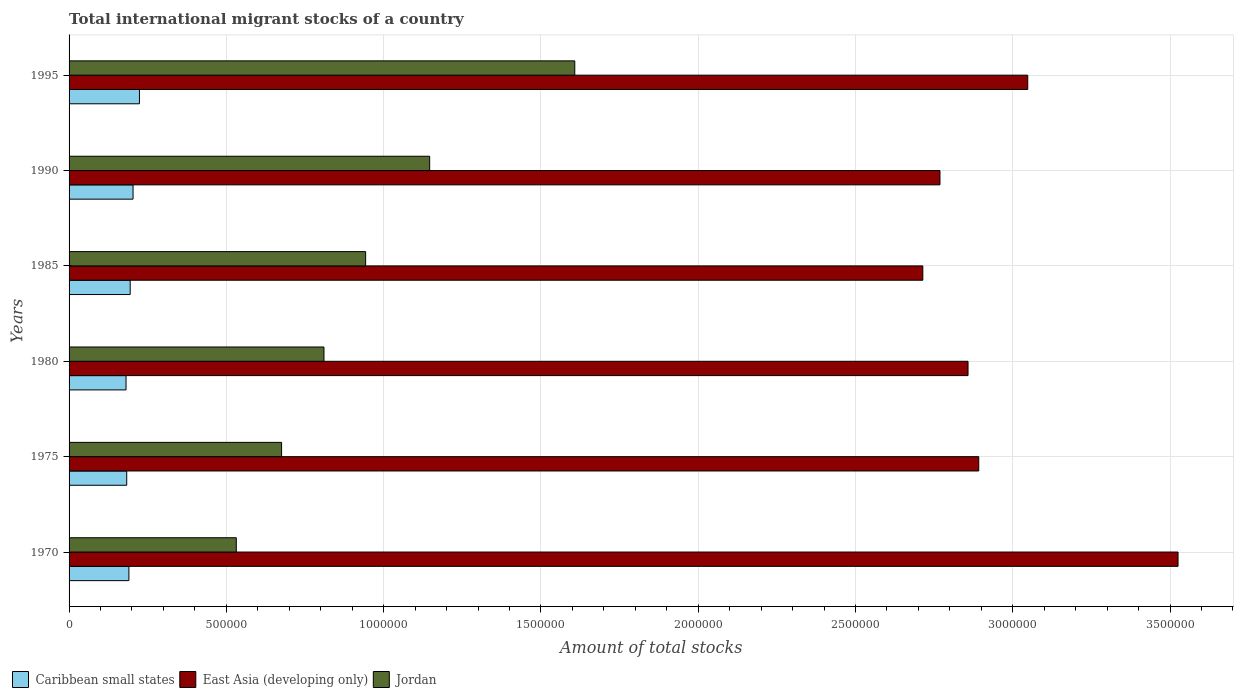How many bars are there on the 6th tick from the top?
Your answer should be compact. 3. How many bars are there on the 2nd tick from the bottom?
Make the answer very short. 3. In how many cases, is the number of bars for a given year not equal to the number of legend labels?
Your response must be concise. 0. What is the amount of total stocks in in Jordan in 1970?
Provide a short and direct response. 5.32e+05. Across all years, what is the maximum amount of total stocks in in Jordan?
Ensure brevity in your answer.  1.61e+06. Across all years, what is the minimum amount of total stocks in in Jordan?
Your answer should be very brief. 5.32e+05. What is the total amount of total stocks in in Caribbean small states in the graph?
Your answer should be very brief. 1.18e+06. What is the difference between the amount of total stocks in in Jordan in 1980 and that in 1985?
Offer a very short reply. -1.32e+05. What is the difference between the amount of total stocks in in Jordan in 1970 and the amount of total stocks in in East Asia (developing only) in 1995?
Make the answer very short. -2.52e+06. What is the average amount of total stocks in in Jordan per year?
Keep it short and to the point. 9.52e+05. In the year 1970, what is the difference between the amount of total stocks in in Caribbean small states and amount of total stocks in in East Asia (developing only)?
Offer a terse response. -3.34e+06. In how many years, is the amount of total stocks in in Caribbean small states greater than 300000 ?
Your answer should be compact. 0. What is the ratio of the amount of total stocks in in Jordan in 1970 to that in 1985?
Keep it short and to the point. 0.56. Is the difference between the amount of total stocks in in Caribbean small states in 1975 and 1990 greater than the difference between the amount of total stocks in in East Asia (developing only) in 1975 and 1990?
Your response must be concise. No. What is the difference between the highest and the second highest amount of total stocks in in East Asia (developing only)?
Provide a succinct answer. 4.78e+05. What is the difference between the highest and the lowest amount of total stocks in in Jordan?
Make the answer very short. 1.08e+06. In how many years, is the amount of total stocks in in Jordan greater than the average amount of total stocks in in Jordan taken over all years?
Ensure brevity in your answer.  2. Is the sum of the amount of total stocks in in East Asia (developing only) in 1970 and 1985 greater than the maximum amount of total stocks in in Jordan across all years?
Your response must be concise. Yes. What does the 1st bar from the top in 1985 represents?
Your answer should be compact. Jordan. What does the 1st bar from the bottom in 1985 represents?
Offer a very short reply. Caribbean small states. Is it the case that in every year, the sum of the amount of total stocks in in Jordan and amount of total stocks in in Caribbean small states is greater than the amount of total stocks in in East Asia (developing only)?
Your answer should be very brief. No. How many bars are there?
Your answer should be very brief. 18. What is the difference between two consecutive major ticks on the X-axis?
Your answer should be compact. 5.00e+05. Are the values on the major ticks of X-axis written in scientific E-notation?
Provide a succinct answer. No. Does the graph contain any zero values?
Provide a short and direct response. No. Where does the legend appear in the graph?
Make the answer very short. Bottom left. How are the legend labels stacked?
Provide a succinct answer. Horizontal. What is the title of the graph?
Provide a succinct answer. Total international migrant stocks of a country. What is the label or title of the X-axis?
Your response must be concise. Amount of total stocks. What is the label or title of the Y-axis?
Keep it short and to the point. Years. What is the Amount of total stocks in Caribbean small states in 1970?
Your answer should be very brief. 1.90e+05. What is the Amount of total stocks in East Asia (developing only) in 1970?
Ensure brevity in your answer.  3.53e+06. What is the Amount of total stocks of Jordan in 1970?
Keep it short and to the point. 5.32e+05. What is the Amount of total stocks in Caribbean small states in 1975?
Ensure brevity in your answer.  1.83e+05. What is the Amount of total stocks in East Asia (developing only) in 1975?
Provide a succinct answer. 2.89e+06. What is the Amount of total stocks in Jordan in 1975?
Give a very brief answer. 6.76e+05. What is the Amount of total stocks of Caribbean small states in 1980?
Provide a short and direct response. 1.81e+05. What is the Amount of total stocks in East Asia (developing only) in 1980?
Provide a succinct answer. 2.86e+06. What is the Amount of total stocks of Jordan in 1980?
Offer a terse response. 8.10e+05. What is the Amount of total stocks of Caribbean small states in 1985?
Your answer should be compact. 1.94e+05. What is the Amount of total stocks in East Asia (developing only) in 1985?
Provide a short and direct response. 2.71e+06. What is the Amount of total stocks of Jordan in 1985?
Provide a short and direct response. 9.43e+05. What is the Amount of total stocks of Caribbean small states in 1990?
Offer a very short reply. 2.03e+05. What is the Amount of total stocks in East Asia (developing only) in 1990?
Offer a terse response. 2.77e+06. What is the Amount of total stocks in Jordan in 1990?
Keep it short and to the point. 1.15e+06. What is the Amount of total stocks of Caribbean small states in 1995?
Ensure brevity in your answer.  2.24e+05. What is the Amount of total stocks of East Asia (developing only) in 1995?
Provide a succinct answer. 3.05e+06. What is the Amount of total stocks in Jordan in 1995?
Your answer should be very brief. 1.61e+06. Across all years, what is the maximum Amount of total stocks of Caribbean small states?
Your answer should be very brief. 2.24e+05. Across all years, what is the maximum Amount of total stocks in East Asia (developing only)?
Offer a very short reply. 3.53e+06. Across all years, what is the maximum Amount of total stocks of Jordan?
Your answer should be compact. 1.61e+06. Across all years, what is the minimum Amount of total stocks in Caribbean small states?
Give a very brief answer. 1.81e+05. Across all years, what is the minimum Amount of total stocks in East Asia (developing only)?
Your answer should be compact. 2.71e+06. Across all years, what is the minimum Amount of total stocks in Jordan?
Provide a short and direct response. 5.32e+05. What is the total Amount of total stocks in Caribbean small states in the graph?
Give a very brief answer. 1.18e+06. What is the total Amount of total stocks of East Asia (developing only) in the graph?
Offer a very short reply. 1.78e+07. What is the total Amount of total stocks of Jordan in the graph?
Provide a short and direct response. 5.71e+06. What is the difference between the Amount of total stocks in Caribbean small states in 1970 and that in 1975?
Give a very brief answer. 6938. What is the difference between the Amount of total stocks of East Asia (developing only) in 1970 and that in 1975?
Your answer should be very brief. 6.34e+05. What is the difference between the Amount of total stocks in Jordan in 1970 and that in 1975?
Give a very brief answer. -1.44e+05. What is the difference between the Amount of total stocks of Caribbean small states in 1970 and that in 1980?
Offer a very short reply. 9108. What is the difference between the Amount of total stocks in East Asia (developing only) in 1970 and that in 1980?
Keep it short and to the point. 6.68e+05. What is the difference between the Amount of total stocks of Jordan in 1970 and that in 1980?
Your response must be concise. -2.79e+05. What is the difference between the Amount of total stocks in Caribbean small states in 1970 and that in 1985?
Make the answer very short. -4065. What is the difference between the Amount of total stocks of East Asia (developing only) in 1970 and that in 1985?
Provide a succinct answer. 8.11e+05. What is the difference between the Amount of total stocks in Jordan in 1970 and that in 1985?
Make the answer very short. -4.11e+05. What is the difference between the Amount of total stocks in Caribbean small states in 1970 and that in 1990?
Keep it short and to the point. -1.32e+04. What is the difference between the Amount of total stocks of East Asia (developing only) in 1970 and that in 1990?
Provide a succinct answer. 7.57e+05. What is the difference between the Amount of total stocks in Jordan in 1970 and that in 1990?
Offer a very short reply. -6.15e+05. What is the difference between the Amount of total stocks in Caribbean small states in 1970 and that in 1995?
Offer a terse response. -3.35e+04. What is the difference between the Amount of total stocks in East Asia (developing only) in 1970 and that in 1995?
Your response must be concise. 4.78e+05. What is the difference between the Amount of total stocks of Jordan in 1970 and that in 1995?
Give a very brief answer. -1.08e+06. What is the difference between the Amount of total stocks in Caribbean small states in 1975 and that in 1980?
Ensure brevity in your answer.  2170. What is the difference between the Amount of total stocks in East Asia (developing only) in 1975 and that in 1980?
Provide a succinct answer. 3.41e+04. What is the difference between the Amount of total stocks in Jordan in 1975 and that in 1980?
Offer a very short reply. -1.35e+05. What is the difference between the Amount of total stocks of Caribbean small states in 1975 and that in 1985?
Offer a very short reply. -1.10e+04. What is the difference between the Amount of total stocks in East Asia (developing only) in 1975 and that in 1985?
Provide a short and direct response. 1.78e+05. What is the difference between the Amount of total stocks of Jordan in 1975 and that in 1985?
Your answer should be compact. -2.67e+05. What is the difference between the Amount of total stocks of Caribbean small states in 1975 and that in 1990?
Make the answer very short. -2.02e+04. What is the difference between the Amount of total stocks of East Asia (developing only) in 1975 and that in 1990?
Give a very brief answer. 1.23e+05. What is the difference between the Amount of total stocks of Jordan in 1975 and that in 1990?
Make the answer very short. -4.71e+05. What is the difference between the Amount of total stocks of Caribbean small states in 1975 and that in 1995?
Provide a short and direct response. -4.05e+04. What is the difference between the Amount of total stocks in East Asia (developing only) in 1975 and that in 1995?
Offer a terse response. -1.56e+05. What is the difference between the Amount of total stocks in Jordan in 1975 and that in 1995?
Keep it short and to the point. -9.32e+05. What is the difference between the Amount of total stocks of Caribbean small states in 1980 and that in 1985?
Offer a very short reply. -1.32e+04. What is the difference between the Amount of total stocks in East Asia (developing only) in 1980 and that in 1985?
Your answer should be compact. 1.44e+05. What is the difference between the Amount of total stocks in Jordan in 1980 and that in 1985?
Your answer should be very brief. -1.32e+05. What is the difference between the Amount of total stocks in Caribbean small states in 1980 and that in 1990?
Keep it short and to the point. -2.23e+04. What is the difference between the Amount of total stocks in East Asia (developing only) in 1980 and that in 1990?
Provide a short and direct response. 8.92e+04. What is the difference between the Amount of total stocks in Jordan in 1980 and that in 1990?
Provide a short and direct response. -3.36e+05. What is the difference between the Amount of total stocks in Caribbean small states in 1980 and that in 1995?
Keep it short and to the point. -4.26e+04. What is the difference between the Amount of total stocks of East Asia (developing only) in 1980 and that in 1995?
Keep it short and to the point. -1.90e+05. What is the difference between the Amount of total stocks in Jordan in 1980 and that in 1995?
Offer a terse response. -7.97e+05. What is the difference between the Amount of total stocks of Caribbean small states in 1985 and that in 1990?
Keep it short and to the point. -9157. What is the difference between the Amount of total stocks in East Asia (developing only) in 1985 and that in 1990?
Provide a succinct answer. -5.45e+04. What is the difference between the Amount of total stocks of Jordan in 1985 and that in 1990?
Make the answer very short. -2.04e+05. What is the difference between the Amount of total stocks of Caribbean small states in 1985 and that in 1995?
Provide a short and direct response. -2.95e+04. What is the difference between the Amount of total stocks in East Asia (developing only) in 1985 and that in 1995?
Your response must be concise. -3.34e+05. What is the difference between the Amount of total stocks in Jordan in 1985 and that in 1995?
Make the answer very short. -6.65e+05. What is the difference between the Amount of total stocks in Caribbean small states in 1990 and that in 1995?
Ensure brevity in your answer.  -2.03e+04. What is the difference between the Amount of total stocks of East Asia (developing only) in 1990 and that in 1995?
Offer a very short reply. -2.79e+05. What is the difference between the Amount of total stocks of Jordan in 1990 and that in 1995?
Your response must be concise. -4.61e+05. What is the difference between the Amount of total stocks of Caribbean small states in 1970 and the Amount of total stocks of East Asia (developing only) in 1975?
Provide a short and direct response. -2.70e+06. What is the difference between the Amount of total stocks of Caribbean small states in 1970 and the Amount of total stocks of Jordan in 1975?
Provide a short and direct response. -4.85e+05. What is the difference between the Amount of total stocks in East Asia (developing only) in 1970 and the Amount of total stocks in Jordan in 1975?
Make the answer very short. 2.85e+06. What is the difference between the Amount of total stocks in Caribbean small states in 1970 and the Amount of total stocks in East Asia (developing only) in 1980?
Your response must be concise. -2.67e+06. What is the difference between the Amount of total stocks in Caribbean small states in 1970 and the Amount of total stocks in Jordan in 1980?
Provide a short and direct response. -6.20e+05. What is the difference between the Amount of total stocks in East Asia (developing only) in 1970 and the Amount of total stocks in Jordan in 1980?
Provide a succinct answer. 2.72e+06. What is the difference between the Amount of total stocks in Caribbean small states in 1970 and the Amount of total stocks in East Asia (developing only) in 1985?
Provide a short and direct response. -2.52e+06. What is the difference between the Amount of total stocks of Caribbean small states in 1970 and the Amount of total stocks of Jordan in 1985?
Your answer should be compact. -7.53e+05. What is the difference between the Amount of total stocks in East Asia (developing only) in 1970 and the Amount of total stocks in Jordan in 1985?
Keep it short and to the point. 2.58e+06. What is the difference between the Amount of total stocks of Caribbean small states in 1970 and the Amount of total stocks of East Asia (developing only) in 1990?
Provide a short and direct response. -2.58e+06. What is the difference between the Amount of total stocks in Caribbean small states in 1970 and the Amount of total stocks in Jordan in 1990?
Provide a short and direct response. -9.56e+05. What is the difference between the Amount of total stocks in East Asia (developing only) in 1970 and the Amount of total stocks in Jordan in 1990?
Keep it short and to the point. 2.38e+06. What is the difference between the Amount of total stocks in Caribbean small states in 1970 and the Amount of total stocks in East Asia (developing only) in 1995?
Your answer should be compact. -2.86e+06. What is the difference between the Amount of total stocks of Caribbean small states in 1970 and the Amount of total stocks of Jordan in 1995?
Offer a very short reply. -1.42e+06. What is the difference between the Amount of total stocks of East Asia (developing only) in 1970 and the Amount of total stocks of Jordan in 1995?
Ensure brevity in your answer.  1.92e+06. What is the difference between the Amount of total stocks in Caribbean small states in 1975 and the Amount of total stocks in East Asia (developing only) in 1980?
Offer a terse response. -2.67e+06. What is the difference between the Amount of total stocks of Caribbean small states in 1975 and the Amount of total stocks of Jordan in 1980?
Provide a succinct answer. -6.27e+05. What is the difference between the Amount of total stocks in East Asia (developing only) in 1975 and the Amount of total stocks in Jordan in 1980?
Your answer should be very brief. 2.08e+06. What is the difference between the Amount of total stocks in Caribbean small states in 1975 and the Amount of total stocks in East Asia (developing only) in 1985?
Provide a succinct answer. -2.53e+06. What is the difference between the Amount of total stocks in Caribbean small states in 1975 and the Amount of total stocks in Jordan in 1985?
Ensure brevity in your answer.  -7.60e+05. What is the difference between the Amount of total stocks in East Asia (developing only) in 1975 and the Amount of total stocks in Jordan in 1985?
Your response must be concise. 1.95e+06. What is the difference between the Amount of total stocks of Caribbean small states in 1975 and the Amount of total stocks of East Asia (developing only) in 1990?
Make the answer very short. -2.59e+06. What is the difference between the Amount of total stocks of Caribbean small states in 1975 and the Amount of total stocks of Jordan in 1990?
Provide a short and direct response. -9.63e+05. What is the difference between the Amount of total stocks in East Asia (developing only) in 1975 and the Amount of total stocks in Jordan in 1990?
Your answer should be compact. 1.75e+06. What is the difference between the Amount of total stocks of Caribbean small states in 1975 and the Amount of total stocks of East Asia (developing only) in 1995?
Ensure brevity in your answer.  -2.86e+06. What is the difference between the Amount of total stocks in Caribbean small states in 1975 and the Amount of total stocks in Jordan in 1995?
Provide a short and direct response. -1.42e+06. What is the difference between the Amount of total stocks in East Asia (developing only) in 1975 and the Amount of total stocks in Jordan in 1995?
Ensure brevity in your answer.  1.28e+06. What is the difference between the Amount of total stocks in Caribbean small states in 1980 and the Amount of total stocks in East Asia (developing only) in 1985?
Provide a short and direct response. -2.53e+06. What is the difference between the Amount of total stocks in Caribbean small states in 1980 and the Amount of total stocks in Jordan in 1985?
Ensure brevity in your answer.  -7.62e+05. What is the difference between the Amount of total stocks in East Asia (developing only) in 1980 and the Amount of total stocks in Jordan in 1985?
Provide a short and direct response. 1.92e+06. What is the difference between the Amount of total stocks in Caribbean small states in 1980 and the Amount of total stocks in East Asia (developing only) in 1990?
Make the answer very short. -2.59e+06. What is the difference between the Amount of total stocks in Caribbean small states in 1980 and the Amount of total stocks in Jordan in 1990?
Your answer should be compact. -9.65e+05. What is the difference between the Amount of total stocks in East Asia (developing only) in 1980 and the Amount of total stocks in Jordan in 1990?
Give a very brief answer. 1.71e+06. What is the difference between the Amount of total stocks in Caribbean small states in 1980 and the Amount of total stocks in East Asia (developing only) in 1995?
Ensure brevity in your answer.  -2.87e+06. What is the difference between the Amount of total stocks in Caribbean small states in 1980 and the Amount of total stocks in Jordan in 1995?
Offer a terse response. -1.43e+06. What is the difference between the Amount of total stocks of East Asia (developing only) in 1980 and the Amount of total stocks of Jordan in 1995?
Provide a short and direct response. 1.25e+06. What is the difference between the Amount of total stocks in Caribbean small states in 1985 and the Amount of total stocks in East Asia (developing only) in 1990?
Offer a very short reply. -2.57e+06. What is the difference between the Amount of total stocks of Caribbean small states in 1985 and the Amount of total stocks of Jordan in 1990?
Make the answer very short. -9.52e+05. What is the difference between the Amount of total stocks of East Asia (developing only) in 1985 and the Amount of total stocks of Jordan in 1990?
Give a very brief answer. 1.57e+06. What is the difference between the Amount of total stocks in Caribbean small states in 1985 and the Amount of total stocks in East Asia (developing only) in 1995?
Offer a terse response. -2.85e+06. What is the difference between the Amount of total stocks of Caribbean small states in 1985 and the Amount of total stocks of Jordan in 1995?
Your response must be concise. -1.41e+06. What is the difference between the Amount of total stocks of East Asia (developing only) in 1985 and the Amount of total stocks of Jordan in 1995?
Ensure brevity in your answer.  1.11e+06. What is the difference between the Amount of total stocks in Caribbean small states in 1990 and the Amount of total stocks in East Asia (developing only) in 1995?
Make the answer very short. -2.84e+06. What is the difference between the Amount of total stocks in Caribbean small states in 1990 and the Amount of total stocks in Jordan in 1995?
Make the answer very short. -1.40e+06. What is the difference between the Amount of total stocks in East Asia (developing only) in 1990 and the Amount of total stocks in Jordan in 1995?
Your answer should be compact. 1.16e+06. What is the average Amount of total stocks in Caribbean small states per year?
Offer a terse response. 1.96e+05. What is the average Amount of total stocks in East Asia (developing only) per year?
Your answer should be compact. 2.97e+06. What is the average Amount of total stocks in Jordan per year?
Offer a terse response. 9.52e+05. In the year 1970, what is the difference between the Amount of total stocks of Caribbean small states and Amount of total stocks of East Asia (developing only)?
Your answer should be compact. -3.34e+06. In the year 1970, what is the difference between the Amount of total stocks of Caribbean small states and Amount of total stocks of Jordan?
Make the answer very short. -3.41e+05. In the year 1970, what is the difference between the Amount of total stocks of East Asia (developing only) and Amount of total stocks of Jordan?
Your answer should be compact. 2.99e+06. In the year 1975, what is the difference between the Amount of total stocks in Caribbean small states and Amount of total stocks in East Asia (developing only)?
Make the answer very short. -2.71e+06. In the year 1975, what is the difference between the Amount of total stocks of Caribbean small states and Amount of total stocks of Jordan?
Your answer should be very brief. -4.92e+05. In the year 1975, what is the difference between the Amount of total stocks of East Asia (developing only) and Amount of total stocks of Jordan?
Your answer should be compact. 2.22e+06. In the year 1980, what is the difference between the Amount of total stocks in Caribbean small states and Amount of total stocks in East Asia (developing only)?
Your answer should be compact. -2.68e+06. In the year 1980, what is the difference between the Amount of total stocks in Caribbean small states and Amount of total stocks in Jordan?
Keep it short and to the point. -6.29e+05. In the year 1980, what is the difference between the Amount of total stocks in East Asia (developing only) and Amount of total stocks in Jordan?
Keep it short and to the point. 2.05e+06. In the year 1985, what is the difference between the Amount of total stocks of Caribbean small states and Amount of total stocks of East Asia (developing only)?
Offer a terse response. -2.52e+06. In the year 1985, what is the difference between the Amount of total stocks of Caribbean small states and Amount of total stocks of Jordan?
Ensure brevity in your answer.  -7.49e+05. In the year 1985, what is the difference between the Amount of total stocks in East Asia (developing only) and Amount of total stocks in Jordan?
Offer a very short reply. 1.77e+06. In the year 1990, what is the difference between the Amount of total stocks of Caribbean small states and Amount of total stocks of East Asia (developing only)?
Provide a succinct answer. -2.57e+06. In the year 1990, what is the difference between the Amount of total stocks of Caribbean small states and Amount of total stocks of Jordan?
Give a very brief answer. -9.43e+05. In the year 1990, what is the difference between the Amount of total stocks in East Asia (developing only) and Amount of total stocks in Jordan?
Keep it short and to the point. 1.62e+06. In the year 1995, what is the difference between the Amount of total stocks in Caribbean small states and Amount of total stocks in East Asia (developing only)?
Your response must be concise. -2.82e+06. In the year 1995, what is the difference between the Amount of total stocks of Caribbean small states and Amount of total stocks of Jordan?
Your answer should be very brief. -1.38e+06. In the year 1995, what is the difference between the Amount of total stocks in East Asia (developing only) and Amount of total stocks in Jordan?
Ensure brevity in your answer.  1.44e+06. What is the ratio of the Amount of total stocks in Caribbean small states in 1970 to that in 1975?
Offer a very short reply. 1.04. What is the ratio of the Amount of total stocks in East Asia (developing only) in 1970 to that in 1975?
Give a very brief answer. 1.22. What is the ratio of the Amount of total stocks in Jordan in 1970 to that in 1975?
Make the answer very short. 0.79. What is the ratio of the Amount of total stocks of Caribbean small states in 1970 to that in 1980?
Provide a succinct answer. 1.05. What is the ratio of the Amount of total stocks in East Asia (developing only) in 1970 to that in 1980?
Keep it short and to the point. 1.23. What is the ratio of the Amount of total stocks in Jordan in 1970 to that in 1980?
Ensure brevity in your answer.  0.66. What is the ratio of the Amount of total stocks of Caribbean small states in 1970 to that in 1985?
Give a very brief answer. 0.98. What is the ratio of the Amount of total stocks of East Asia (developing only) in 1970 to that in 1985?
Make the answer very short. 1.3. What is the ratio of the Amount of total stocks of Jordan in 1970 to that in 1985?
Make the answer very short. 0.56. What is the ratio of the Amount of total stocks in Caribbean small states in 1970 to that in 1990?
Your answer should be compact. 0.94. What is the ratio of the Amount of total stocks of East Asia (developing only) in 1970 to that in 1990?
Provide a short and direct response. 1.27. What is the ratio of the Amount of total stocks in Jordan in 1970 to that in 1990?
Provide a short and direct response. 0.46. What is the ratio of the Amount of total stocks of Caribbean small states in 1970 to that in 1995?
Your response must be concise. 0.85. What is the ratio of the Amount of total stocks in East Asia (developing only) in 1970 to that in 1995?
Your answer should be compact. 1.16. What is the ratio of the Amount of total stocks of Jordan in 1970 to that in 1995?
Keep it short and to the point. 0.33. What is the ratio of the Amount of total stocks of East Asia (developing only) in 1975 to that in 1980?
Offer a terse response. 1.01. What is the ratio of the Amount of total stocks in Jordan in 1975 to that in 1980?
Offer a very short reply. 0.83. What is the ratio of the Amount of total stocks in Caribbean small states in 1975 to that in 1985?
Keep it short and to the point. 0.94. What is the ratio of the Amount of total stocks in East Asia (developing only) in 1975 to that in 1985?
Keep it short and to the point. 1.07. What is the ratio of the Amount of total stocks in Jordan in 1975 to that in 1985?
Keep it short and to the point. 0.72. What is the ratio of the Amount of total stocks in Caribbean small states in 1975 to that in 1990?
Give a very brief answer. 0.9. What is the ratio of the Amount of total stocks of East Asia (developing only) in 1975 to that in 1990?
Provide a succinct answer. 1.04. What is the ratio of the Amount of total stocks of Jordan in 1975 to that in 1990?
Keep it short and to the point. 0.59. What is the ratio of the Amount of total stocks of Caribbean small states in 1975 to that in 1995?
Offer a very short reply. 0.82. What is the ratio of the Amount of total stocks in East Asia (developing only) in 1975 to that in 1995?
Your answer should be very brief. 0.95. What is the ratio of the Amount of total stocks in Jordan in 1975 to that in 1995?
Ensure brevity in your answer.  0.42. What is the ratio of the Amount of total stocks of Caribbean small states in 1980 to that in 1985?
Your answer should be compact. 0.93. What is the ratio of the Amount of total stocks of East Asia (developing only) in 1980 to that in 1985?
Provide a short and direct response. 1.05. What is the ratio of the Amount of total stocks of Jordan in 1980 to that in 1985?
Offer a terse response. 0.86. What is the ratio of the Amount of total stocks of Caribbean small states in 1980 to that in 1990?
Provide a succinct answer. 0.89. What is the ratio of the Amount of total stocks of East Asia (developing only) in 1980 to that in 1990?
Provide a short and direct response. 1.03. What is the ratio of the Amount of total stocks in Jordan in 1980 to that in 1990?
Your answer should be very brief. 0.71. What is the ratio of the Amount of total stocks of Caribbean small states in 1980 to that in 1995?
Your answer should be compact. 0.81. What is the ratio of the Amount of total stocks in East Asia (developing only) in 1980 to that in 1995?
Your answer should be very brief. 0.94. What is the ratio of the Amount of total stocks in Jordan in 1980 to that in 1995?
Your answer should be compact. 0.5. What is the ratio of the Amount of total stocks of Caribbean small states in 1985 to that in 1990?
Your answer should be compact. 0.95. What is the ratio of the Amount of total stocks in East Asia (developing only) in 1985 to that in 1990?
Your answer should be compact. 0.98. What is the ratio of the Amount of total stocks of Jordan in 1985 to that in 1990?
Provide a succinct answer. 0.82. What is the ratio of the Amount of total stocks in Caribbean small states in 1985 to that in 1995?
Provide a short and direct response. 0.87. What is the ratio of the Amount of total stocks of East Asia (developing only) in 1985 to that in 1995?
Your answer should be compact. 0.89. What is the ratio of the Amount of total stocks in Jordan in 1985 to that in 1995?
Your answer should be very brief. 0.59. What is the ratio of the Amount of total stocks in Caribbean small states in 1990 to that in 1995?
Your answer should be very brief. 0.91. What is the ratio of the Amount of total stocks in East Asia (developing only) in 1990 to that in 1995?
Offer a very short reply. 0.91. What is the ratio of the Amount of total stocks of Jordan in 1990 to that in 1995?
Keep it short and to the point. 0.71. What is the difference between the highest and the second highest Amount of total stocks of Caribbean small states?
Your response must be concise. 2.03e+04. What is the difference between the highest and the second highest Amount of total stocks of East Asia (developing only)?
Offer a terse response. 4.78e+05. What is the difference between the highest and the second highest Amount of total stocks in Jordan?
Your response must be concise. 4.61e+05. What is the difference between the highest and the lowest Amount of total stocks in Caribbean small states?
Give a very brief answer. 4.26e+04. What is the difference between the highest and the lowest Amount of total stocks of East Asia (developing only)?
Your response must be concise. 8.11e+05. What is the difference between the highest and the lowest Amount of total stocks in Jordan?
Keep it short and to the point. 1.08e+06. 